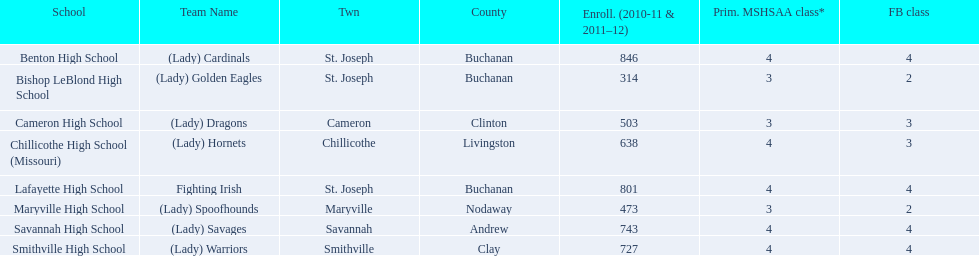What are all of the schools? Benton High School, Bishop LeBlond High School, Cameron High School, Chillicothe High School (Missouri), Lafayette High School, Maryville High School, Savannah High School, Smithville High School. How many football classes do they have? 4, 2, 3, 3, 4, 2, 4, 4. What about their enrollment? 846, 314, 503, 638, 801, 473, 743, 727. Which schools have 3 football classes? Cameron High School, Chillicothe High School (Missouri). And of those schools, which has 638 students? Chillicothe High School (Missouri). 